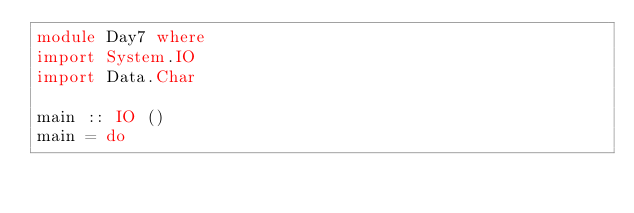Convert code to text. <code><loc_0><loc_0><loc_500><loc_500><_Haskell_>module Day7 where
import System.IO
import Data.Char

main :: IO ()
main = do</code> 